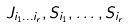<formula> <loc_0><loc_0><loc_500><loc_500>J _ { i _ { 1 } \dots i _ { r } } , S _ { i _ { 1 } } , \dots , S _ { i _ { r } }</formula> 